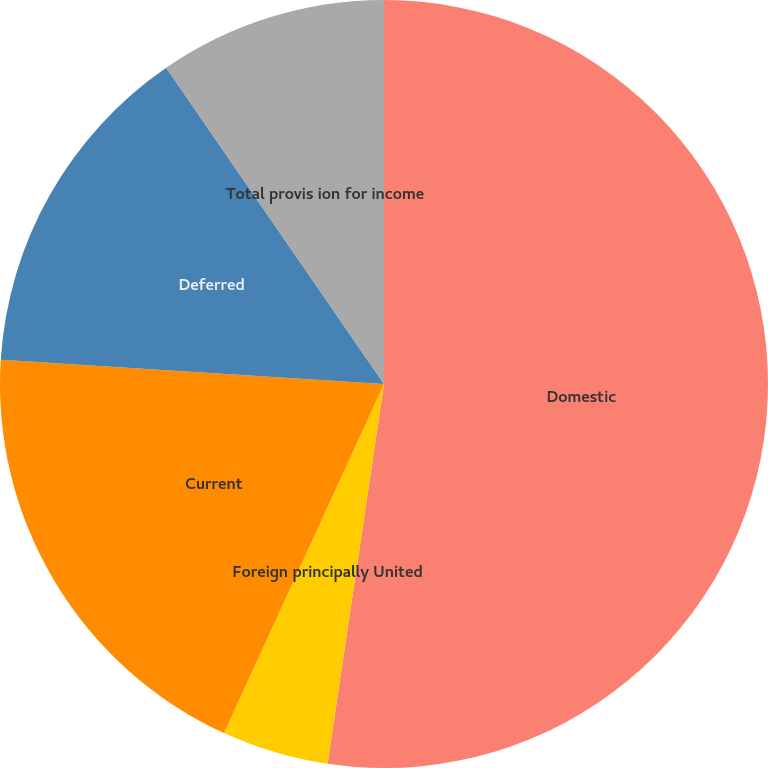Convert chart. <chart><loc_0><loc_0><loc_500><loc_500><pie_chart><fcel>Domestic<fcel>Foreign principally United<fcel>Current<fcel>Deferred<fcel>Total provis ion for income<nl><fcel>52.35%<fcel>4.49%<fcel>19.17%<fcel>14.39%<fcel>9.6%<nl></chart> 